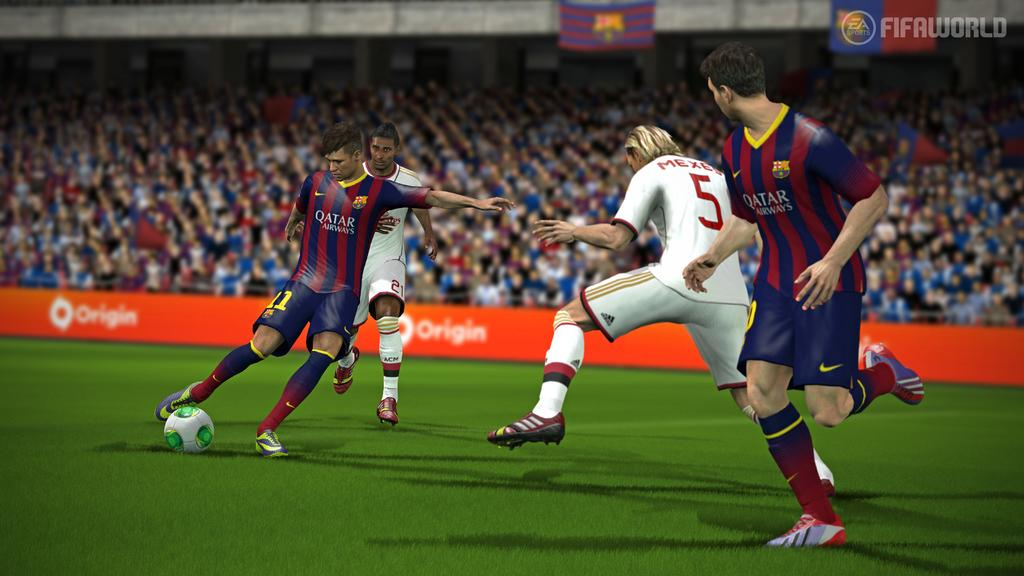Provide a one-sentence caption for the provided image. A soccer video game shows an image of a player in a jersey with the text Qatar Airways who is getting reading to shoot a soccer ball. 